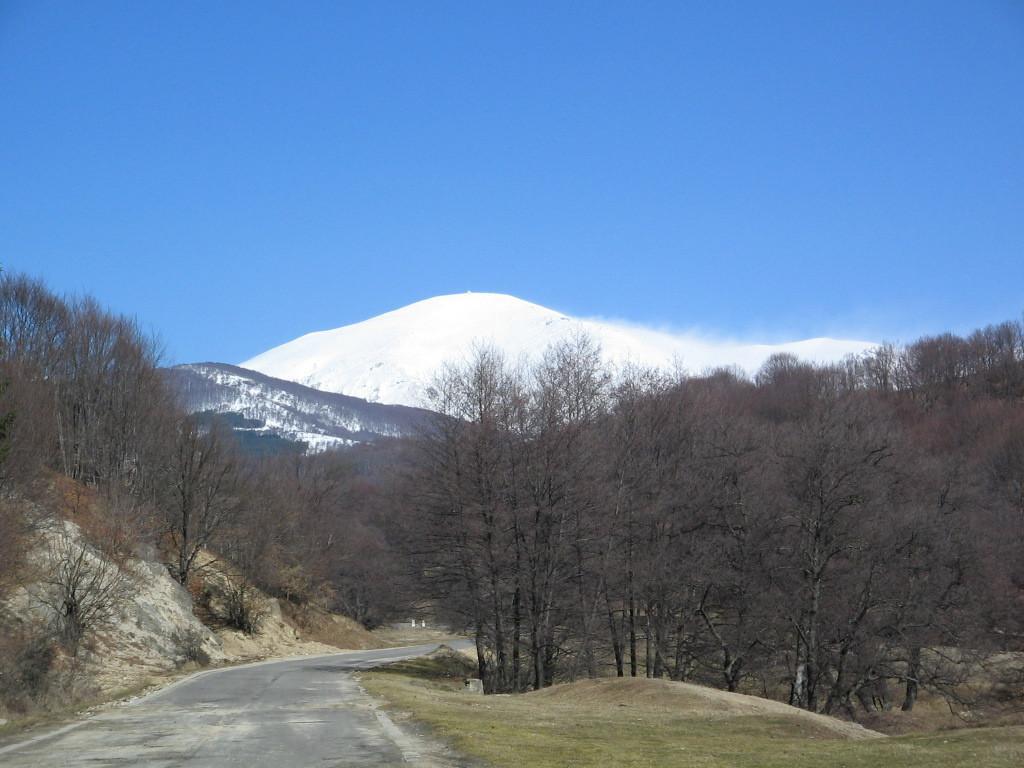Please provide a concise description of this image. In this image I can see a road, number of trees, mountains and the sky in the background. 